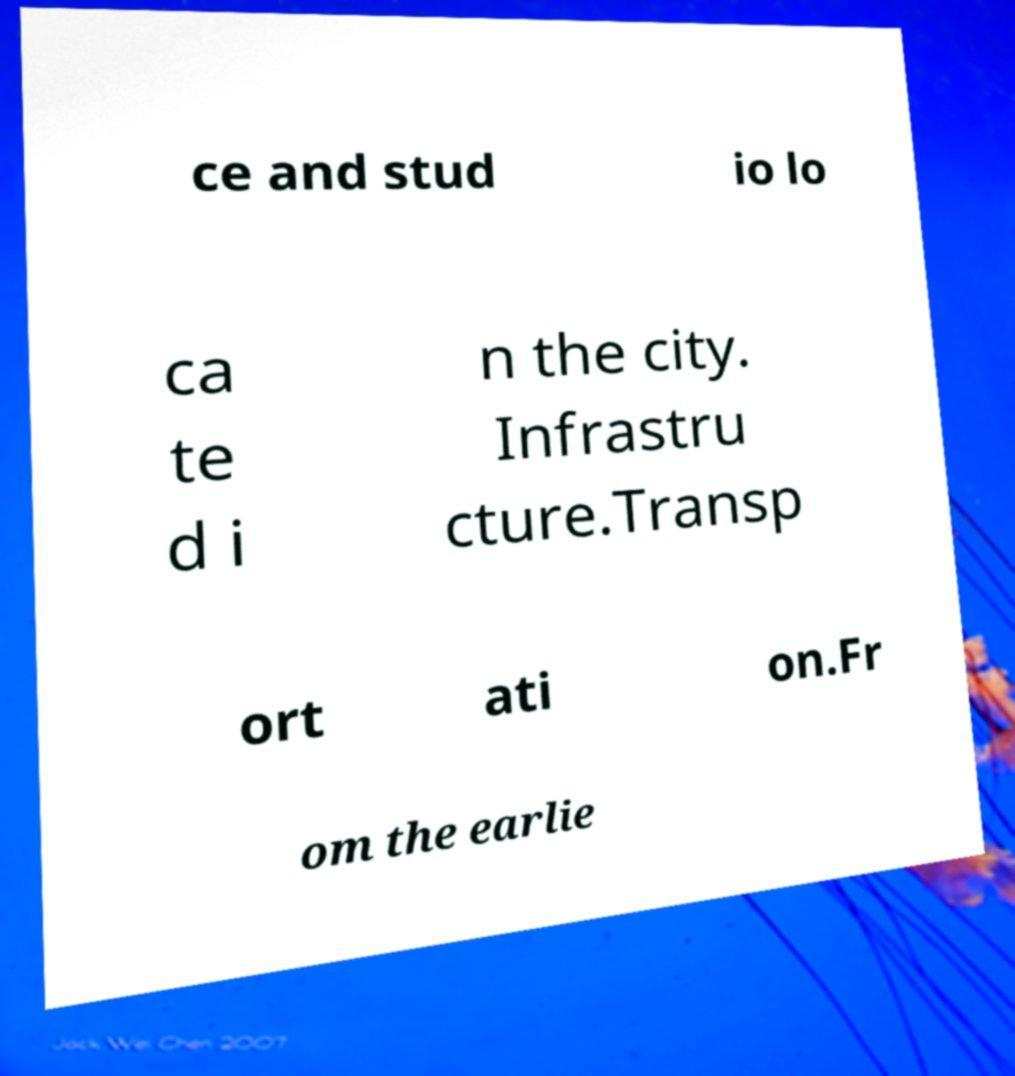There's text embedded in this image that I need extracted. Can you transcribe it verbatim? ce and stud io lo ca te d i n the city. Infrastru cture.Transp ort ati on.Fr om the earlie 